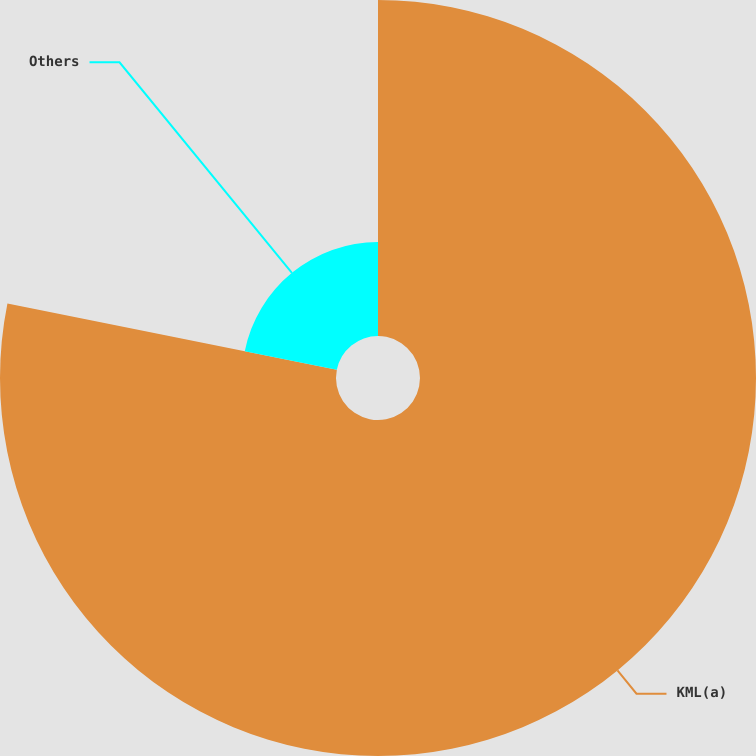<chart> <loc_0><loc_0><loc_500><loc_500><pie_chart><fcel>KML(a)<fcel>Others<nl><fcel>78.16%<fcel>21.84%<nl></chart> 